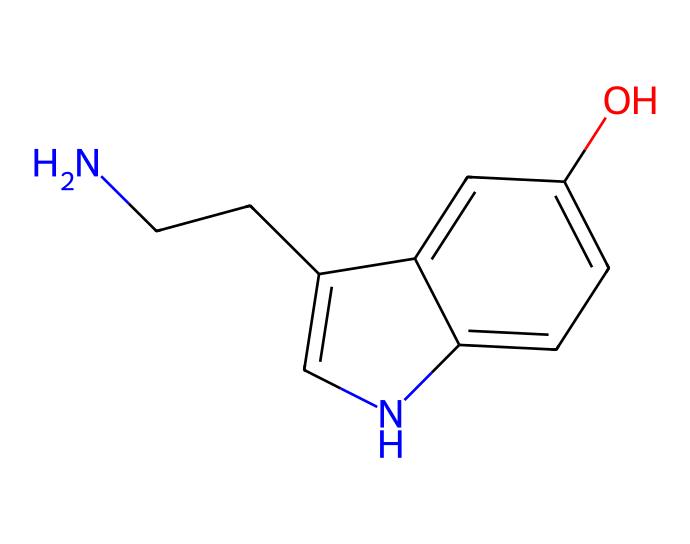How many carbon atoms are present in the chemical? Counting the carbon atoms in the SMILES notation, we identify six 'C's (from NCCc1c and the aromatic ring structure), confirming there are six carbon atoms.
Answer: six What functional group is present in this molecule? The molecule contains a hydroxyl group (-OH), indicated by the 'O' connected to a carbon in the aromatic ring structure.
Answer: hydroxyl group How many nitrogen atoms are found in this compound? The SMILES notation includes two 'N's located at the beginning and at the aromatic ring, thus there are two nitrogen atoms in total.
Answer: two What type of bond connects the nitrogen to the carbon in the main chain? In the SMILES representation, the nitrogen (N) is followed by a carbon (C) with no additional characters between them, indicating a single bond.
Answer: single bond What is the molecular formula of serotonin based on its SMILES? To derive the molecular formula, we count the atoms from the SMILES: C:6, H:6, N:2, O:1, resulting in the formula C10H12N2O.
Answer: C10H12N2O How many rings are present in the structure of this molecule? Analyzing the representation reveals that there are two interconnected rings: one with the nitrogen and the other with the hydroxyl group, totaling two rings in the structure.
Answer: two rings Which part of the molecule contributes to its role as a neurotransmitter? The amine group (from the nitrogen atoms) along with the aromatic system participates in neurotransmission, particularly influencing serotonin's receptor interactions.
Answer: amine group 